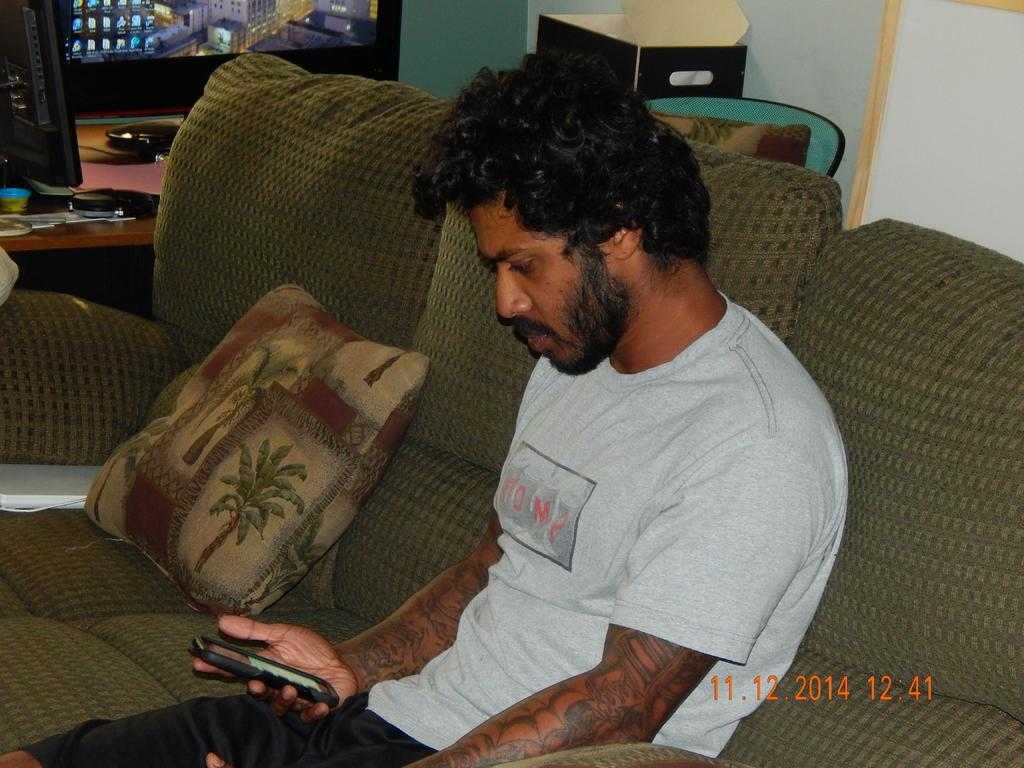What is the person in the image doing? The person is sitting on the couch. What is the person holding in the image? The person is holding a mobile. What can be seen to the right of the person? There are objects to the right of the person. What is located on a table in the image? There is a system on a table in the image. Where is the toothbrush located in the image? There is no toothbrush present in the image. What type of pen is the person using to write on the system in the image? There is no pen or writing activity present in the image. 